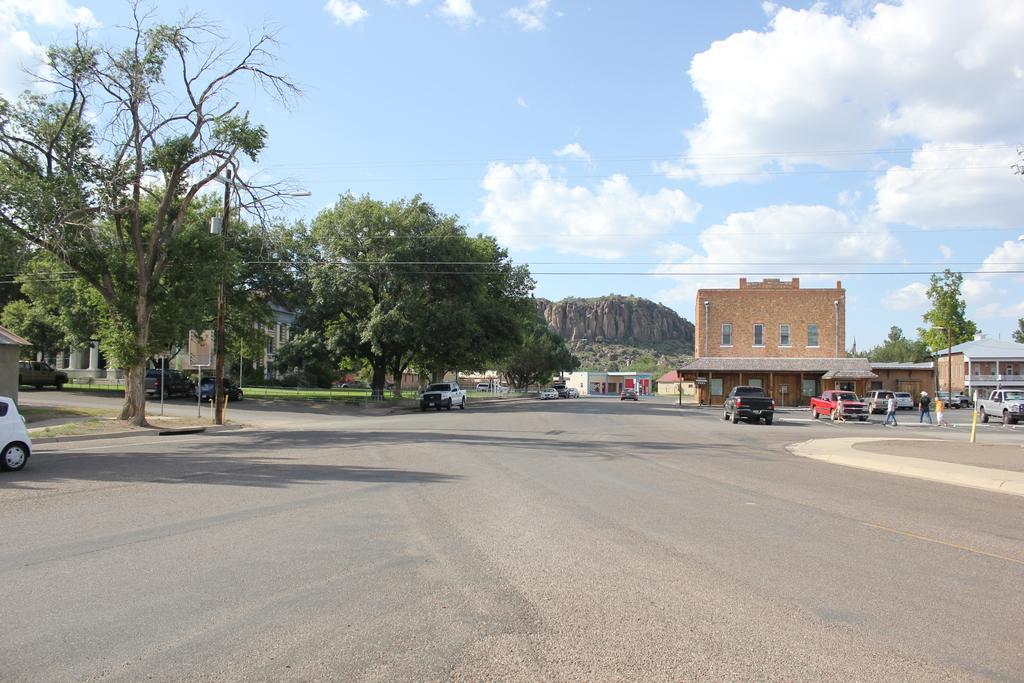Please provide a concise description of this image. In this image I can see few trees, fencing, buildings, sky, poles, wires, windows, rock, sky, few people and few vehicles on the road. 